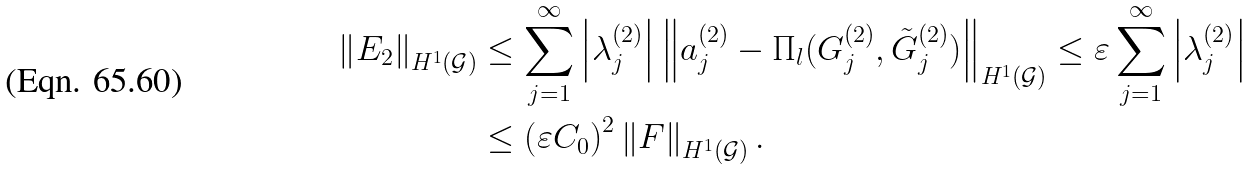<formula> <loc_0><loc_0><loc_500><loc_500>\left \| E _ { 2 } \right \| _ { H ^ { 1 } ( \mathcal { G } ) } & \leq \sum _ { j = 1 } ^ { \infty } \left | \lambda _ { j } ^ { ( 2 ) } \right | \left \| a _ { j } ^ { ( 2 ) } - \Pi _ { l } ( G _ { j } ^ { ( 2 ) } , \tilde { G } _ { j } ^ { ( 2 ) } ) \right \| _ { H ^ { 1 } ( \mathcal { G } ) } \leq \varepsilon \sum _ { j = 1 } ^ { \infty } \left | \lambda _ { j } ^ { ( 2 ) } \right | \\ & \leq \left ( \varepsilon C _ { 0 } \right ) ^ { 2 } \left \| F \right \| _ { H ^ { 1 } ( \mathcal { G } ) } .</formula> 